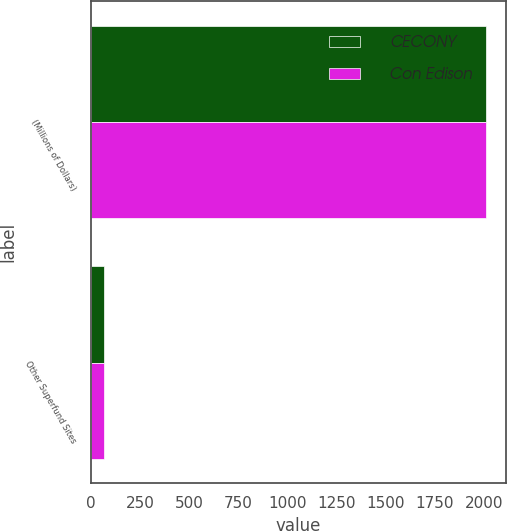Convert chart. <chart><loc_0><loc_0><loc_500><loc_500><stacked_bar_chart><ecel><fcel>(Millions of Dollars)<fcel>Other Superfund Sites<nl><fcel>CECONY<fcel>2011<fcel>67<nl><fcel>Con Edison<fcel>2011<fcel>66<nl></chart> 